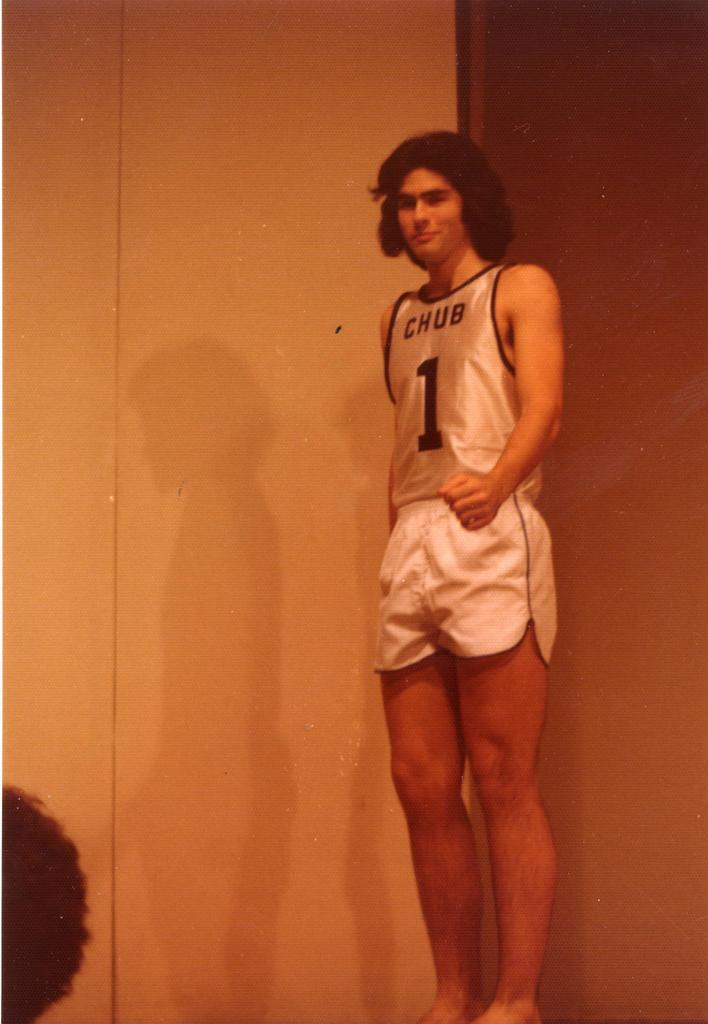<image>
Provide a brief description of the given image. A young man in a white jersey that says Chub. 